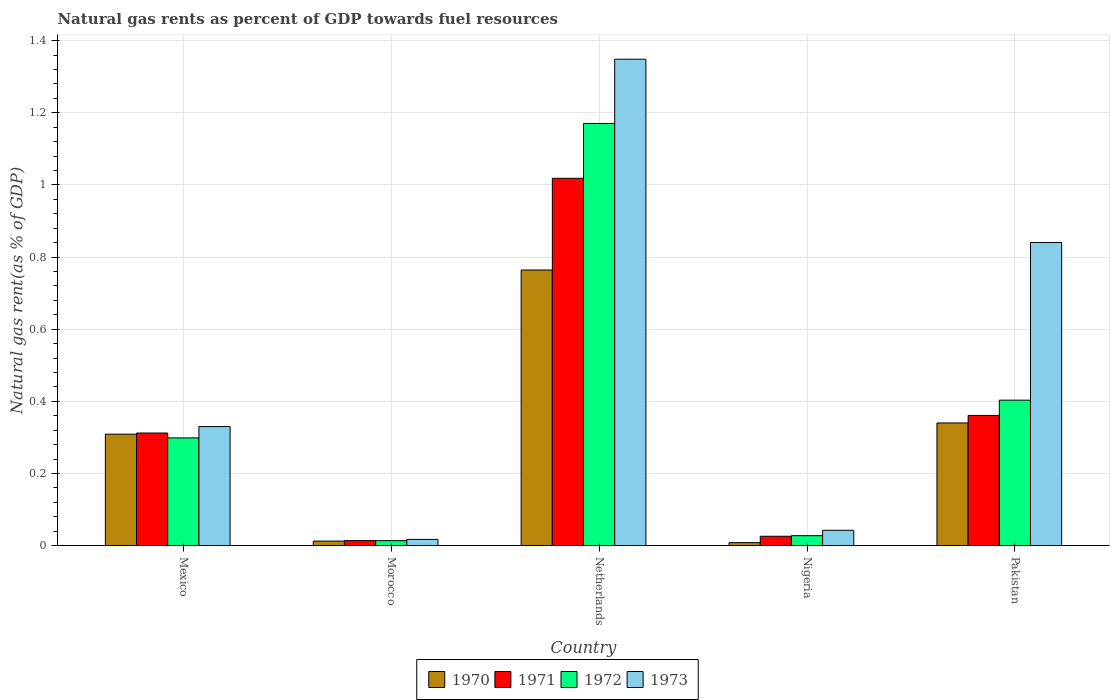How many different coloured bars are there?
Make the answer very short. 4. Are the number of bars per tick equal to the number of legend labels?
Keep it short and to the point. Yes. How many bars are there on the 5th tick from the right?
Your response must be concise. 4. What is the label of the 3rd group of bars from the left?
Provide a short and direct response. Netherlands. In how many cases, is the number of bars for a given country not equal to the number of legend labels?
Make the answer very short. 0. What is the natural gas rent in 1972 in Nigeria?
Provide a short and direct response. 0.03. Across all countries, what is the maximum natural gas rent in 1971?
Ensure brevity in your answer.  1.02. Across all countries, what is the minimum natural gas rent in 1970?
Your response must be concise. 0.01. In which country was the natural gas rent in 1972 minimum?
Offer a very short reply. Morocco. What is the total natural gas rent in 1971 in the graph?
Your answer should be very brief. 1.73. What is the difference between the natural gas rent in 1971 in Mexico and that in Nigeria?
Your answer should be very brief. 0.29. What is the difference between the natural gas rent in 1973 in Pakistan and the natural gas rent in 1970 in Mexico?
Ensure brevity in your answer.  0.53. What is the average natural gas rent in 1970 per country?
Your answer should be compact. 0.29. What is the difference between the natural gas rent of/in 1973 and natural gas rent of/in 1970 in Morocco?
Provide a succinct answer. 0. What is the ratio of the natural gas rent in 1970 in Morocco to that in Nigeria?
Provide a succinct answer. 1.52. What is the difference between the highest and the second highest natural gas rent in 1973?
Keep it short and to the point. -0.51. What is the difference between the highest and the lowest natural gas rent in 1971?
Ensure brevity in your answer.  1. In how many countries, is the natural gas rent in 1973 greater than the average natural gas rent in 1973 taken over all countries?
Give a very brief answer. 2. Is it the case that in every country, the sum of the natural gas rent in 1971 and natural gas rent in 1973 is greater than the sum of natural gas rent in 1970 and natural gas rent in 1972?
Your response must be concise. Yes. What does the 1st bar from the right in Pakistan represents?
Keep it short and to the point. 1973. How many bars are there?
Offer a very short reply. 20. How many countries are there in the graph?
Offer a very short reply. 5. Are the values on the major ticks of Y-axis written in scientific E-notation?
Make the answer very short. No. Does the graph contain any zero values?
Offer a terse response. No. Does the graph contain grids?
Keep it short and to the point. Yes. How are the legend labels stacked?
Offer a very short reply. Horizontal. What is the title of the graph?
Your answer should be very brief. Natural gas rents as percent of GDP towards fuel resources. What is the label or title of the X-axis?
Offer a very short reply. Country. What is the label or title of the Y-axis?
Your answer should be very brief. Natural gas rent(as % of GDP). What is the Natural gas rent(as % of GDP) in 1970 in Mexico?
Provide a short and direct response. 0.31. What is the Natural gas rent(as % of GDP) of 1971 in Mexico?
Provide a short and direct response. 0.31. What is the Natural gas rent(as % of GDP) in 1972 in Mexico?
Keep it short and to the point. 0.3. What is the Natural gas rent(as % of GDP) of 1973 in Mexico?
Make the answer very short. 0.33. What is the Natural gas rent(as % of GDP) in 1970 in Morocco?
Your answer should be very brief. 0.01. What is the Natural gas rent(as % of GDP) of 1971 in Morocco?
Make the answer very short. 0.01. What is the Natural gas rent(as % of GDP) of 1972 in Morocco?
Keep it short and to the point. 0.01. What is the Natural gas rent(as % of GDP) of 1973 in Morocco?
Your answer should be compact. 0.02. What is the Natural gas rent(as % of GDP) of 1970 in Netherlands?
Make the answer very short. 0.76. What is the Natural gas rent(as % of GDP) in 1971 in Netherlands?
Ensure brevity in your answer.  1.02. What is the Natural gas rent(as % of GDP) of 1972 in Netherlands?
Your answer should be very brief. 1.17. What is the Natural gas rent(as % of GDP) of 1973 in Netherlands?
Your response must be concise. 1.35. What is the Natural gas rent(as % of GDP) of 1970 in Nigeria?
Your answer should be very brief. 0.01. What is the Natural gas rent(as % of GDP) of 1971 in Nigeria?
Provide a short and direct response. 0.03. What is the Natural gas rent(as % of GDP) in 1972 in Nigeria?
Keep it short and to the point. 0.03. What is the Natural gas rent(as % of GDP) of 1973 in Nigeria?
Ensure brevity in your answer.  0.04. What is the Natural gas rent(as % of GDP) of 1970 in Pakistan?
Keep it short and to the point. 0.34. What is the Natural gas rent(as % of GDP) in 1971 in Pakistan?
Provide a succinct answer. 0.36. What is the Natural gas rent(as % of GDP) in 1972 in Pakistan?
Keep it short and to the point. 0.4. What is the Natural gas rent(as % of GDP) of 1973 in Pakistan?
Offer a terse response. 0.84. Across all countries, what is the maximum Natural gas rent(as % of GDP) in 1970?
Give a very brief answer. 0.76. Across all countries, what is the maximum Natural gas rent(as % of GDP) of 1971?
Offer a very short reply. 1.02. Across all countries, what is the maximum Natural gas rent(as % of GDP) in 1972?
Provide a succinct answer. 1.17. Across all countries, what is the maximum Natural gas rent(as % of GDP) of 1973?
Your response must be concise. 1.35. Across all countries, what is the minimum Natural gas rent(as % of GDP) in 1970?
Provide a short and direct response. 0.01. Across all countries, what is the minimum Natural gas rent(as % of GDP) in 1971?
Provide a short and direct response. 0.01. Across all countries, what is the minimum Natural gas rent(as % of GDP) of 1972?
Give a very brief answer. 0.01. Across all countries, what is the minimum Natural gas rent(as % of GDP) of 1973?
Your answer should be compact. 0.02. What is the total Natural gas rent(as % of GDP) in 1970 in the graph?
Ensure brevity in your answer.  1.43. What is the total Natural gas rent(as % of GDP) of 1971 in the graph?
Provide a succinct answer. 1.73. What is the total Natural gas rent(as % of GDP) of 1972 in the graph?
Make the answer very short. 1.91. What is the total Natural gas rent(as % of GDP) in 1973 in the graph?
Provide a succinct answer. 2.58. What is the difference between the Natural gas rent(as % of GDP) of 1970 in Mexico and that in Morocco?
Provide a short and direct response. 0.3. What is the difference between the Natural gas rent(as % of GDP) of 1971 in Mexico and that in Morocco?
Provide a short and direct response. 0.3. What is the difference between the Natural gas rent(as % of GDP) of 1972 in Mexico and that in Morocco?
Provide a short and direct response. 0.28. What is the difference between the Natural gas rent(as % of GDP) in 1973 in Mexico and that in Morocco?
Keep it short and to the point. 0.31. What is the difference between the Natural gas rent(as % of GDP) of 1970 in Mexico and that in Netherlands?
Give a very brief answer. -0.46. What is the difference between the Natural gas rent(as % of GDP) in 1971 in Mexico and that in Netherlands?
Your response must be concise. -0.71. What is the difference between the Natural gas rent(as % of GDP) of 1972 in Mexico and that in Netherlands?
Offer a very short reply. -0.87. What is the difference between the Natural gas rent(as % of GDP) of 1973 in Mexico and that in Netherlands?
Ensure brevity in your answer.  -1.02. What is the difference between the Natural gas rent(as % of GDP) in 1970 in Mexico and that in Nigeria?
Offer a very short reply. 0.3. What is the difference between the Natural gas rent(as % of GDP) of 1971 in Mexico and that in Nigeria?
Keep it short and to the point. 0.29. What is the difference between the Natural gas rent(as % of GDP) in 1972 in Mexico and that in Nigeria?
Offer a very short reply. 0.27. What is the difference between the Natural gas rent(as % of GDP) in 1973 in Mexico and that in Nigeria?
Provide a short and direct response. 0.29. What is the difference between the Natural gas rent(as % of GDP) of 1970 in Mexico and that in Pakistan?
Provide a short and direct response. -0.03. What is the difference between the Natural gas rent(as % of GDP) of 1971 in Mexico and that in Pakistan?
Make the answer very short. -0.05. What is the difference between the Natural gas rent(as % of GDP) of 1972 in Mexico and that in Pakistan?
Give a very brief answer. -0.1. What is the difference between the Natural gas rent(as % of GDP) of 1973 in Mexico and that in Pakistan?
Ensure brevity in your answer.  -0.51. What is the difference between the Natural gas rent(as % of GDP) of 1970 in Morocco and that in Netherlands?
Make the answer very short. -0.75. What is the difference between the Natural gas rent(as % of GDP) of 1971 in Morocco and that in Netherlands?
Your response must be concise. -1. What is the difference between the Natural gas rent(as % of GDP) in 1972 in Morocco and that in Netherlands?
Make the answer very short. -1.16. What is the difference between the Natural gas rent(as % of GDP) of 1973 in Morocco and that in Netherlands?
Your answer should be compact. -1.33. What is the difference between the Natural gas rent(as % of GDP) in 1970 in Morocco and that in Nigeria?
Make the answer very short. 0. What is the difference between the Natural gas rent(as % of GDP) in 1971 in Morocco and that in Nigeria?
Your response must be concise. -0.01. What is the difference between the Natural gas rent(as % of GDP) of 1972 in Morocco and that in Nigeria?
Make the answer very short. -0.01. What is the difference between the Natural gas rent(as % of GDP) in 1973 in Morocco and that in Nigeria?
Your response must be concise. -0.03. What is the difference between the Natural gas rent(as % of GDP) of 1970 in Morocco and that in Pakistan?
Ensure brevity in your answer.  -0.33. What is the difference between the Natural gas rent(as % of GDP) in 1971 in Morocco and that in Pakistan?
Ensure brevity in your answer.  -0.35. What is the difference between the Natural gas rent(as % of GDP) in 1972 in Morocco and that in Pakistan?
Your answer should be compact. -0.39. What is the difference between the Natural gas rent(as % of GDP) of 1973 in Morocco and that in Pakistan?
Give a very brief answer. -0.82. What is the difference between the Natural gas rent(as % of GDP) of 1970 in Netherlands and that in Nigeria?
Your answer should be very brief. 0.76. What is the difference between the Natural gas rent(as % of GDP) of 1972 in Netherlands and that in Nigeria?
Offer a very short reply. 1.14. What is the difference between the Natural gas rent(as % of GDP) of 1973 in Netherlands and that in Nigeria?
Keep it short and to the point. 1.31. What is the difference between the Natural gas rent(as % of GDP) in 1970 in Netherlands and that in Pakistan?
Offer a terse response. 0.42. What is the difference between the Natural gas rent(as % of GDP) in 1971 in Netherlands and that in Pakistan?
Offer a very short reply. 0.66. What is the difference between the Natural gas rent(as % of GDP) in 1972 in Netherlands and that in Pakistan?
Provide a succinct answer. 0.77. What is the difference between the Natural gas rent(as % of GDP) in 1973 in Netherlands and that in Pakistan?
Offer a terse response. 0.51. What is the difference between the Natural gas rent(as % of GDP) in 1970 in Nigeria and that in Pakistan?
Your response must be concise. -0.33. What is the difference between the Natural gas rent(as % of GDP) in 1971 in Nigeria and that in Pakistan?
Provide a succinct answer. -0.34. What is the difference between the Natural gas rent(as % of GDP) in 1972 in Nigeria and that in Pakistan?
Offer a terse response. -0.38. What is the difference between the Natural gas rent(as % of GDP) of 1973 in Nigeria and that in Pakistan?
Make the answer very short. -0.8. What is the difference between the Natural gas rent(as % of GDP) in 1970 in Mexico and the Natural gas rent(as % of GDP) in 1971 in Morocco?
Keep it short and to the point. 0.3. What is the difference between the Natural gas rent(as % of GDP) in 1970 in Mexico and the Natural gas rent(as % of GDP) in 1972 in Morocco?
Keep it short and to the point. 0.3. What is the difference between the Natural gas rent(as % of GDP) in 1970 in Mexico and the Natural gas rent(as % of GDP) in 1973 in Morocco?
Offer a very short reply. 0.29. What is the difference between the Natural gas rent(as % of GDP) in 1971 in Mexico and the Natural gas rent(as % of GDP) in 1972 in Morocco?
Ensure brevity in your answer.  0.3. What is the difference between the Natural gas rent(as % of GDP) in 1971 in Mexico and the Natural gas rent(as % of GDP) in 1973 in Morocco?
Provide a short and direct response. 0.29. What is the difference between the Natural gas rent(as % of GDP) of 1972 in Mexico and the Natural gas rent(as % of GDP) of 1973 in Morocco?
Provide a short and direct response. 0.28. What is the difference between the Natural gas rent(as % of GDP) of 1970 in Mexico and the Natural gas rent(as % of GDP) of 1971 in Netherlands?
Your response must be concise. -0.71. What is the difference between the Natural gas rent(as % of GDP) of 1970 in Mexico and the Natural gas rent(as % of GDP) of 1972 in Netherlands?
Your answer should be very brief. -0.86. What is the difference between the Natural gas rent(as % of GDP) in 1970 in Mexico and the Natural gas rent(as % of GDP) in 1973 in Netherlands?
Your answer should be very brief. -1.04. What is the difference between the Natural gas rent(as % of GDP) of 1971 in Mexico and the Natural gas rent(as % of GDP) of 1972 in Netherlands?
Keep it short and to the point. -0.86. What is the difference between the Natural gas rent(as % of GDP) in 1971 in Mexico and the Natural gas rent(as % of GDP) in 1973 in Netherlands?
Make the answer very short. -1.04. What is the difference between the Natural gas rent(as % of GDP) in 1972 in Mexico and the Natural gas rent(as % of GDP) in 1973 in Netherlands?
Keep it short and to the point. -1.05. What is the difference between the Natural gas rent(as % of GDP) in 1970 in Mexico and the Natural gas rent(as % of GDP) in 1971 in Nigeria?
Your answer should be compact. 0.28. What is the difference between the Natural gas rent(as % of GDP) of 1970 in Mexico and the Natural gas rent(as % of GDP) of 1972 in Nigeria?
Ensure brevity in your answer.  0.28. What is the difference between the Natural gas rent(as % of GDP) in 1970 in Mexico and the Natural gas rent(as % of GDP) in 1973 in Nigeria?
Ensure brevity in your answer.  0.27. What is the difference between the Natural gas rent(as % of GDP) in 1971 in Mexico and the Natural gas rent(as % of GDP) in 1972 in Nigeria?
Ensure brevity in your answer.  0.28. What is the difference between the Natural gas rent(as % of GDP) of 1971 in Mexico and the Natural gas rent(as % of GDP) of 1973 in Nigeria?
Give a very brief answer. 0.27. What is the difference between the Natural gas rent(as % of GDP) of 1972 in Mexico and the Natural gas rent(as % of GDP) of 1973 in Nigeria?
Make the answer very short. 0.26. What is the difference between the Natural gas rent(as % of GDP) of 1970 in Mexico and the Natural gas rent(as % of GDP) of 1971 in Pakistan?
Provide a succinct answer. -0.05. What is the difference between the Natural gas rent(as % of GDP) of 1970 in Mexico and the Natural gas rent(as % of GDP) of 1972 in Pakistan?
Make the answer very short. -0.09. What is the difference between the Natural gas rent(as % of GDP) in 1970 in Mexico and the Natural gas rent(as % of GDP) in 1973 in Pakistan?
Your answer should be compact. -0.53. What is the difference between the Natural gas rent(as % of GDP) of 1971 in Mexico and the Natural gas rent(as % of GDP) of 1972 in Pakistan?
Your response must be concise. -0.09. What is the difference between the Natural gas rent(as % of GDP) in 1971 in Mexico and the Natural gas rent(as % of GDP) in 1973 in Pakistan?
Your answer should be very brief. -0.53. What is the difference between the Natural gas rent(as % of GDP) in 1972 in Mexico and the Natural gas rent(as % of GDP) in 1973 in Pakistan?
Ensure brevity in your answer.  -0.54. What is the difference between the Natural gas rent(as % of GDP) of 1970 in Morocco and the Natural gas rent(as % of GDP) of 1971 in Netherlands?
Offer a very short reply. -1.01. What is the difference between the Natural gas rent(as % of GDP) in 1970 in Morocco and the Natural gas rent(as % of GDP) in 1972 in Netherlands?
Provide a short and direct response. -1.16. What is the difference between the Natural gas rent(as % of GDP) in 1970 in Morocco and the Natural gas rent(as % of GDP) in 1973 in Netherlands?
Offer a terse response. -1.34. What is the difference between the Natural gas rent(as % of GDP) of 1971 in Morocco and the Natural gas rent(as % of GDP) of 1972 in Netherlands?
Provide a succinct answer. -1.16. What is the difference between the Natural gas rent(as % of GDP) of 1971 in Morocco and the Natural gas rent(as % of GDP) of 1973 in Netherlands?
Make the answer very short. -1.33. What is the difference between the Natural gas rent(as % of GDP) in 1972 in Morocco and the Natural gas rent(as % of GDP) in 1973 in Netherlands?
Keep it short and to the point. -1.34. What is the difference between the Natural gas rent(as % of GDP) in 1970 in Morocco and the Natural gas rent(as % of GDP) in 1971 in Nigeria?
Provide a short and direct response. -0.01. What is the difference between the Natural gas rent(as % of GDP) in 1970 in Morocco and the Natural gas rent(as % of GDP) in 1972 in Nigeria?
Make the answer very short. -0.02. What is the difference between the Natural gas rent(as % of GDP) of 1970 in Morocco and the Natural gas rent(as % of GDP) of 1973 in Nigeria?
Your response must be concise. -0.03. What is the difference between the Natural gas rent(as % of GDP) in 1971 in Morocco and the Natural gas rent(as % of GDP) in 1972 in Nigeria?
Offer a very short reply. -0.01. What is the difference between the Natural gas rent(as % of GDP) of 1971 in Morocco and the Natural gas rent(as % of GDP) of 1973 in Nigeria?
Provide a succinct answer. -0.03. What is the difference between the Natural gas rent(as % of GDP) of 1972 in Morocco and the Natural gas rent(as % of GDP) of 1973 in Nigeria?
Provide a short and direct response. -0.03. What is the difference between the Natural gas rent(as % of GDP) of 1970 in Morocco and the Natural gas rent(as % of GDP) of 1971 in Pakistan?
Provide a succinct answer. -0.35. What is the difference between the Natural gas rent(as % of GDP) of 1970 in Morocco and the Natural gas rent(as % of GDP) of 1972 in Pakistan?
Your response must be concise. -0.39. What is the difference between the Natural gas rent(as % of GDP) of 1970 in Morocco and the Natural gas rent(as % of GDP) of 1973 in Pakistan?
Your response must be concise. -0.83. What is the difference between the Natural gas rent(as % of GDP) of 1971 in Morocco and the Natural gas rent(as % of GDP) of 1972 in Pakistan?
Ensure brevity in your answer.  -0.39. What is the difference between the Natural gas rent(as % of GDP) of 1971 in Morocco and the Natural gas rent(as % of GDP) of 1973 in Pakistan?
Your response must be concise. -0.83. What is the difference between the Natural gas rent(as % of GDP) in 1972 in Morocco and the Natural gas rent(as % of GDP) in 1973 in Pakistan?
Your response must be concise. -0.83. What is the difference between the Natural gas rent(as % of GDP) of 1970 in Netherlands and the Natural gas rent(as % of GDP) of 1971 in Nigeria?
Ensure brevity in your answer.  0.74. What is the difference between the Natural gas rent(as % of GDP) of 1970 in Netherlands and the Natural gas rent(as % of GDP) of 1972 in Nigeria?
Ensure brevity in your answer.  0.74. What is the difference between the Natural gas rent(as % of GDP) in 1970 in Netherlands and the Natural gas rent(as % of GDP) in 1973 in Nigeria?
Offer a very short reply. 0.72. What is the difference between the Natural gas rent(as % of GDP) in 1971 in Netherlands and the Natural gas rent(as % of GDP) in 1972 in Nigeria?
Your answer should be compact. 0.99. What is the difference between the Natural gas rent(as % of GDP) of 1972 in Netherlands and the Natural gas rent(as % of GDP) of 1973 in Nigeria?
Provide a short and direct response. 1.13. What is the difference between the Natural gas rent(as % of GDP) in 1970 in Netherlands and the Natural gas rent(as % of GDP) in 1971 in Pakistan?
Make the answer very short. 0.4. What is the difference between the Natural gas rent(as % of GDP) in 1970 in Netherlands and the Natural gas rent(as % of GDP) in 1972 in Pakistan?
Provide a short and direct response. 0.36. What is the difference between the Natural gas rent(as % of GDP) in 1970 in Netherlands and the Natural gas rent(as % of GDP) in 1973 in Pakistan?
Provide a short and direct response. -0.08. What is the difference between the Natural gas rent(as % of GDP) of 1971 in Netherlands and the Natural gas rent(as % of GDP) of 1972 in Pakistan?
Provide a short and direct response. 0.62. What is the difference between the Natural gas rent(as % of GDP) of 1971 in Netherlands and the Natural gas rent(as % of GDP) of 1973 in Pakistan?
Keep it short and to the point. 0.18. What is the difference between the Natural gas rent(as % of GDP) in 1972 in Netherlands and the Natural gas rent(as % of GDP) in 1973 in Pakistan?
Give a very brief answer. 0.33. What is the difference between the Natural gas rent(as % of GDP) of 1970 in Nigeria and the Natural gas rent(as % of GDP) of 1971 in Pakistan?
Your answer should be very brief. -0.35. What is the difference between the Natural gas rent(as % of GDP) of 1970 in Nigeria and the Natural gas rent(as % of GDP) of 1972 in Pakistan?
Provide a succinct answer. -0.4. What is the difference between the Natural gas rent(as % of GDP) of 1970 in Nigeria and the Natural gas rent(as % of GDP) of 1973 in Pakistan?
Give a very brief answer. -0.83. What is the difference between the Natural gas rent(as % of GDP) in 1971 in Nigeria and the Natural gas rent(as % of GDP) in 1972 in Pakistan?
Provide a succinct answer. -0.38. What is the difference between the Natural gas rent(as % of GDP) in 1971 in Nigeria and the Natural gas rent(as % of GDP) in 1973 in Pakistan?
Provide a succinct answer. -0.81. What is the difference between the Natural gas rent(as % of GDP) of 1972 in Nigeria and the Natural gas rent(as % of GDP) of 1973 in Pakistan?
Provide a succinct answer. -0.81. What is the average Natural gas rent(as % of GDP) in 1970 per country?
Ensure brevity in your answer.  0.29. What is the average Natural gas rent(as % of GDP) in 1971 per country?
Your response must be concise. 0.35. What is the average Natural gas rent(as % of GDP) in 1972 per country?
Keep it short and to the point. 0.38. What is the average Natural gas rent(as % of GDP) of 1973 per country?
Your response must be concise. 0.52. What is the difference between the Natural gas rent(as % of GDP) of 1970 and Natural gas rent(as % of GDP) of 1971 in Mexico?
Your answer should be very brief. -0. What is the difference between the Natural gas rent(as % of GDP) in 1970 and Natural gas rent(as % of GDP) in 1972 in Mexico?
Make the answer very short. 0.01. What is the difference between the Natural gas rent(as % of GDP) of 1970 and Natural gas rent(as % of GDP) of 1973 in Mexico?
Keep it short and to the point. -0.02. What is the difference between the Natural gas rent(as % of GDP) of 1971 and Natural gas rent(as % of GDP) of 1972 in Mexico?
Ensure brevity in your answer.  0.01. What is the difference between the Natural gas rent(as % of GDP) of 1971 and Natural gas rent(as % of GDP) of 1973 in Mexico?
Your answer should be compact. -0.02. What is the difference between the Natural gas rent(as % of GDP) of 1972 and Natural gas rent(as % of GDP) of 1973 in Mexico?
Provide a succinct answer. -0.03. What is the difference between the Natural gas rent(as % of GDP) in 1970 and Natural gas rent(as % of GDP) in 1971 in Morocco?
Your answer should be compact. -0. What is the difference between the Natural gas rent(as % of GDP) in 1970 and Natural gas rent(as % of GDP) in 1972 in Morocco?
Your response must be concise. -0. What is the difference between the Natural gas rent(as % of GDP) in 1970 and Natural gas rent(as % of GDP) in 1973 in Morocco?
Provide a short and direct response. -0. What is the difference between the Natural gas rent(as % of GDP) of 1971 and Natural gas rent(as % of GDP) of 1973 in Morocco?
Make the answer very short. -0. What is the difference between the Natural gas rent(as % of GDP) in 1972 and Natural gas rent(as % of GDP) in 1973 in Morocco?
Provide a succinct answer. -0. What is the difference between the Natural gas rent(as % of GDP) in 1970 and Natural gas rent(as % of GDP) in 1971 in Netherlands?
Your response must be concise. -0.25. What is the difference between the Natural gas rent(as % of GDP) of 1970 and Natural gas rent(as % of GDP) of 1972 in Netherlands?
Offer a very short reply. -0.41. What is the difference between the Natural gas rent(as % of GDP) of 1970 and Natural gas rent(as % of GDP) of 1973 in Netherlands?
Ensure brevity in your answer.  -0.58. What is the difference between the Natural gas rent(as % of GDP) in 1971 and Natural gas rent(as % of GDP) in 1972 in Netherlands?
Make the answer very short. -0.15. What is the difference between the Natural gas rent(as % of GDP) of 1971 and Natural gas rent(as % of GDP) of 1973 in Netherlands?
Provide a short and direct response. -0.33. What is the difference between the Natural gas rent(as % of GDP) of 1972 and Natural gas rent(as % of GDP) of 1973 in Netherlands?
Your answer should be very brief. -0.18. What is the difference between the Natural gas rent(as % of GDP) of 1970 and Natural gas rent(as % of GDP) of 1971 in Nigeria?
Make the answer very short. -0.02. What is the difference between the Natural gas rent(as % of GDP) of 1970 and Natural gas rent(as % of GDP) of 1972 in Nigeria?
Offer a very short reply. -0.02. What is the difference between the Natural gas rent(as % of GDP) in 1970 and Natural gas rent(as % of GDP) in 1973 in Nigeria?
Provide a succinct answer. -0.03. What is the difference between the Natural gas rent(as % of GDP) of 1971 and Natural gas rent(as % of GDP) of 1972 in Nigeria?
Keep it short and to the point. -0. What is the difference between the Natural gas rent(as % of GDP) in 1971 and Natural gas rent(as % of GDP) in 1973 in Nigeria?
Provide a short and direct response. -0.02. What is the difference between the Natural gas rent(as % of GDP) of 1972 and Natural gas rent(as % of GDP) of 1973 in Nigeria?
Give a very brief answer. -0.01. What is the difference between the Natural gas rent(as % of GDP) in 1970 and Natural gas rent(as % of GDP) in 1971 in Pakistan?
Offer a terse response. -0.02. What is the difference between the Natural gas rent(as % of GDP) of 1970 and Natural gas rent(as % of GDP) of 1972 in Pakistan?
Offer a terse response. -0.06. What is the difference between the Natural gas rent(as % of GDP) of 1970 and Natural gas rent(as % of GDP) of 1973 in Pakistan?
Your answer should be compact. -0.5. What is the difference between the Natural gas rent(as % of GDP) in 1971 and Natural gas rent(as % of GDP) in 1972 in Pakistan?
Your response must be concise. -0.04. What is the difference between the Natural gas rent(as % of GDP) in 1971 and Natural gas rent(as % of GDP) in 1973 in Pakistan?
Your answer should be very brief. -0.48. What is the difference between the Natural gas rent(as % of GDP) of 1972 and Natural gas rent(as % of GDP) of 1973 in Pakistan?
Provide a short and direct response. -0.44. What is the ratio of the Natural gas rent(as % of GDP) in 1970 in Mexico to that in Morocco?
Offer a terse response. 25. What is the ratio of the Natural gas rent(as % of GDP) in 1971 in Mexico to that in Morocco?
Your response must be concise. 22.74. What is the ratio of the Natural gas rent(as % of GDP) of 1972 in Mexico to that in Morocco?
Give a very brief answer. 22.04. What is the ratio of the Natural gas rent(as % of GDP) of 1973 in Mexico to that in Morocco?
Make the answer very short. 19.3. What is the ratio of the Natural gas rent(as % of GDP) in 1970 in Mexico to that in Netherlands?
Give a very brief answer. 0.4. What is the ratio of the Natural gas rent(as % of GDP) in 1971 in Mexico to that in Netherlands?
Your answer should be very brief. 0.31. What is the ratio of the Natural gas rent(as % of GDP) of 1972 in Mexico to that in Netherlands?
Your response must be concise. 0.26. What is the ratio of the Natural gas rent(as % of GDP) in 1973 in Mexico to that in Netherlands?
Ensure brevity in your answer.  0.24. What is the ratio of the Natural gas rent(as % of GDP) of 1970 in Mexico to that in Nigeria?
Keep it short and to the point. 37.97. What is the ratio of the Natural gas rent(as % of GDP) in 1971 in Mexico to that in Nigeria?
Offer a very short reply. 12.1. What is the ratio of the Natural gas rent(as % of GDP) in 1972 in Mexico to that in Nigeria?
Offer a very short reply. 10.89. What is the ratio of the Natural gas rent(as % of GDP) in 1973 in Mexico to that in Nigeria?
Make the answer very short. 7.79. What is the ratio of the Natural gas rent(as % of GDP) of 1970 in Mexico to that in Pakistan?
Your response must be concise. 0.91. What is the ratio of the Natural gas rent(as % of GDP) of 1971 in Mexico to that in Pakistan?
Ensure brevity in your answer.  0.86. What is the ratio of the Natural gas rent(as % of GDP) in 1972 in Mexico to that in Pakistan?
Keep it short and to the point. 0.74. What is the ratio of the Natural gas rent(as % of GDP) of 1973 in Mexico to that in Pakistan?
Your answer should be compact. 0.39. What is the ratio of the Natural gas rent(as % of GDP) of 1970 in Morocco to that in Netherlands?
Offer a very short reply. 0.02. What is the ratio of the Natural gas rent(as % of GDP) of 1971 in Morocco to that in Netherlands?
Keep it short and to the point. 0.01. What is the ratio of the Natural gas rent(as % of GDP) of 1972 in Morocco to that in Netherlands?
Make the answer very short. 0.01. What is the ratio of the Natural gas rent(as % of GDP) in 1973 in Morocco to that in Netherlands?
Your answer should be very brief. 0.01. What is the ratio of the Natural gas rent(as % of GDP) of 1970 in Morocco to that in Nigeria?
Your answer should be very brief. 1.52. What is the ratio of the Natural gas rent(as % of GDP) of 1971 in Morocco to that in Nigeria?
Your answer should be compact. 0.53. What is the ratio of the Natural gas rent(as % of GDP) in 1972 in Morocco to that in Nigeria?
Your response must be concise. 0.49. What is the ratio of the Natural gas rent(as % of GDP) in 1973 in Morocco to that in Nigeria?
Make the answer very short. 0.4. What is the ratio of the Natural gas rent(as % of GDP) of 1970 in Morocco to that in Pakistan?
Give a very brief answer. 0.04. What is the ratio of the Natural gas rent(as % of GDP) of 1971 in Morocco to that in Pakistan?
Ensure brevity in your answer.  0.04. What is the ratio of the Natural gas rent(as % of GDP) in 1972 in Morocco to that in Pakistan?
Your answer should be very brief. 0.03. What is the ratio of the Natural gas rent(as % of GDP) of 1973 in Morocco to that in Pakistan?
Keep it short and to the point. 0.02. What is the ratio of the Natural gas rent(as % of GDP) of 1970 in Netherlands to that in Nigeria?
Your response must be concise. 93.94. What is the ratio of the Natural gas rent(as % of GDP) in 1971 in Netherlands to that in Nigeria?
Your response must be concise. 39.48. What is the ratio of the Natural gas rent(as % of GDP) of 1972 in Netherlands to that in Nigeria?
Provide a succinct answer. 42.7. What is the ratio of the Natural gas rent(as % of GDP) in 1973 in Netherlands to that in Nigeria?
Offer a very short reply. 31.84. What is the ratio of the Natural gas rent(as % of GDP) of 1970 in Netherlands to that in Pakistan?
Keep it short and to the point. 2.25. What is the ratio of the Natural gas rent(as % of GDP) of 1971 in Netherlands to that in Pakistan?
Offer a terse response. 2.82. What is the ratio of the Natural gas rent(as % of GDP) of 1972 in Netherlands to that in Pakistan?
Offer a very short reply. 2.9. What is the ratio of the Natural gas rent(as % of GDP) in 1973 in Netherlands to that in Pakistan?
Your answer should be very brief. 1.6. What is the ratio of the Natural gas rent(as % of GDP) of 1970 in Nigeria to that in Pakistan?
Provide a short and direct response. 0.02. What is the ratio of the Natural gas rent(as % of GDP) in 1971 in Nigeria to that in Pakistan?
Your answer should be compact. 0.07. What is the ratio of the Natural gas rent(as % of GDP) in 1972 in Nigeria to that in Pakistan?
Give a very brief answer. 0.07. What is the ratio of the Natural gas rent(as % of GDP) of 1973 in Nigeria to that in Pakistan?
Your answer should be very brief. 0.05. What is the difference between the highest and the second highest Natural gas rent(as % of GDP) of 1970?
Provide a succinct answer. 0.42. What is the difference between the highest and the second highest Natural gas rent(as % of GDP) of 1971?
Ensure brevity in your answer.  0.66. What is the difference between the highest and the second highest Natural gas rent(as % of GDP) of 1972?
Ensure brevity in your answer.  0.77. What is the difference between the highest and the second highest Natural gas rent(as % of GDP) of 1973?
Keep it short and to the point. 0.51. What is the difference between the highest and the lowest Natural gas rent(as % of GDP) of 1970?
Provide a succinct answer. 0.76. What is the difference between the highest and the lowest Natural gas rent(as % of GDP) in 1972?
Provide a succinct answer. 1.16. What is the difference between the highest and the lowest Natural gas rent(as % of GDP) of 1973?
Ensure brevity in your answer.  1.33. 